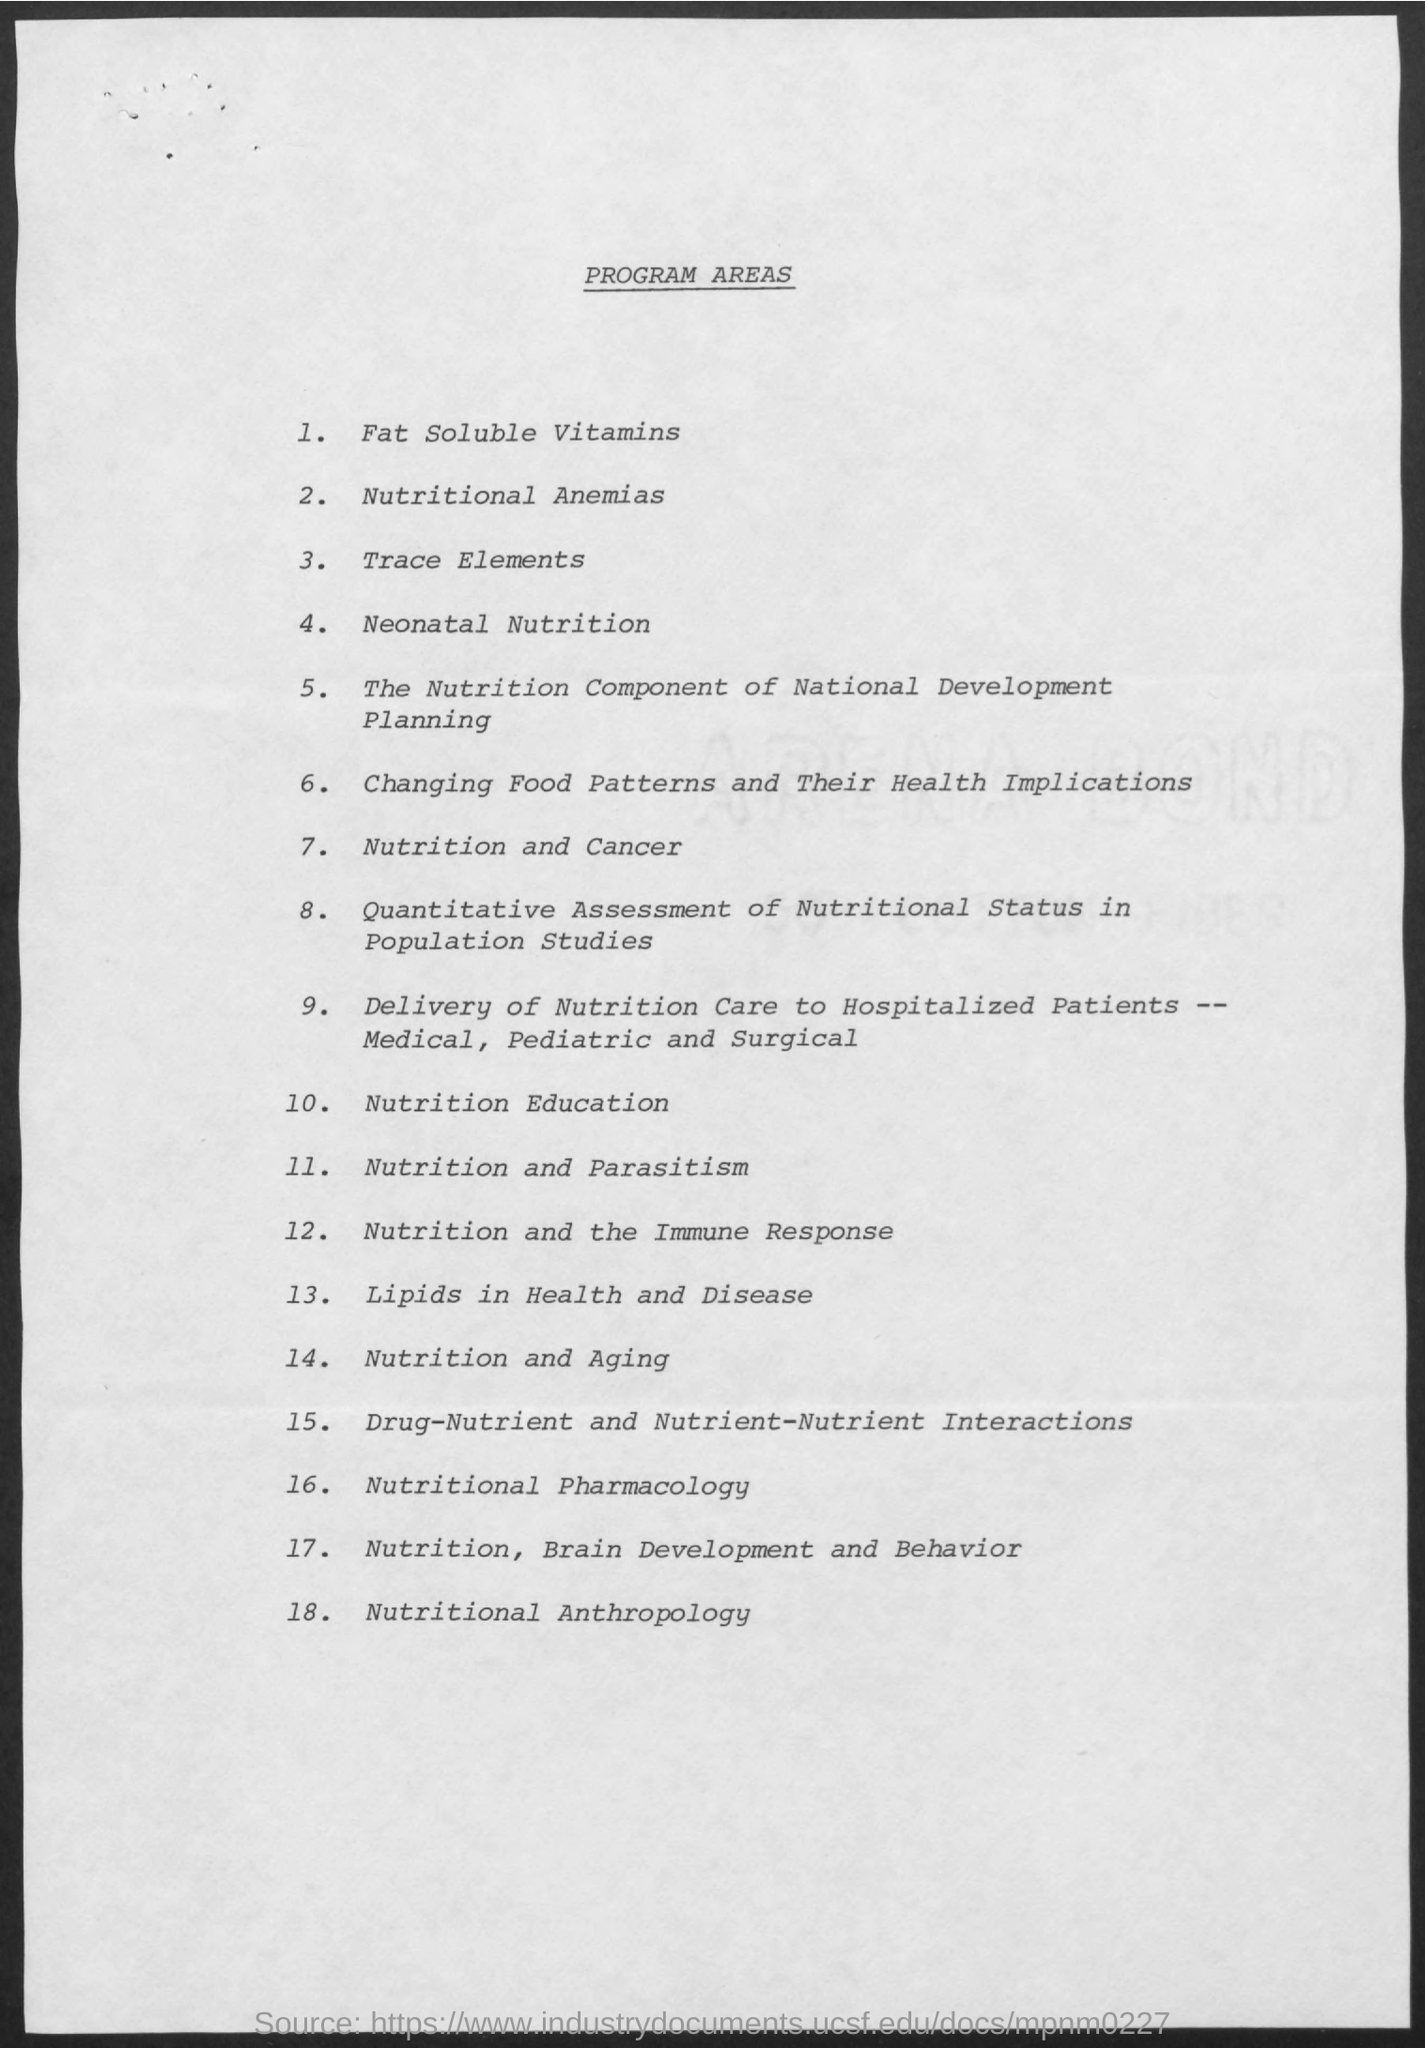Give some essential details in this illustration. Program area number 14 in the document is nutrition and aging. Program Area Number 1 in the document pertains to fat-soluble vitamins. Program area number 10 in the document is nutrition education. Program area number 3 in the document is titled 'Trace Elements'. The title of the document is "Program Areas. 